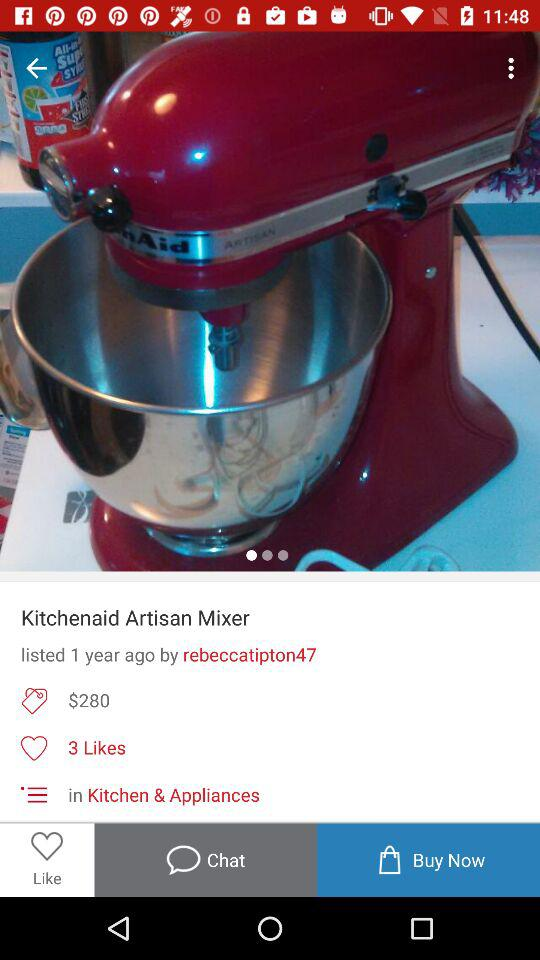What is the number of likes on the Kitchenaid Artisan Mixer? The Kitchenaid Artisan Mixer has 3 likes. 